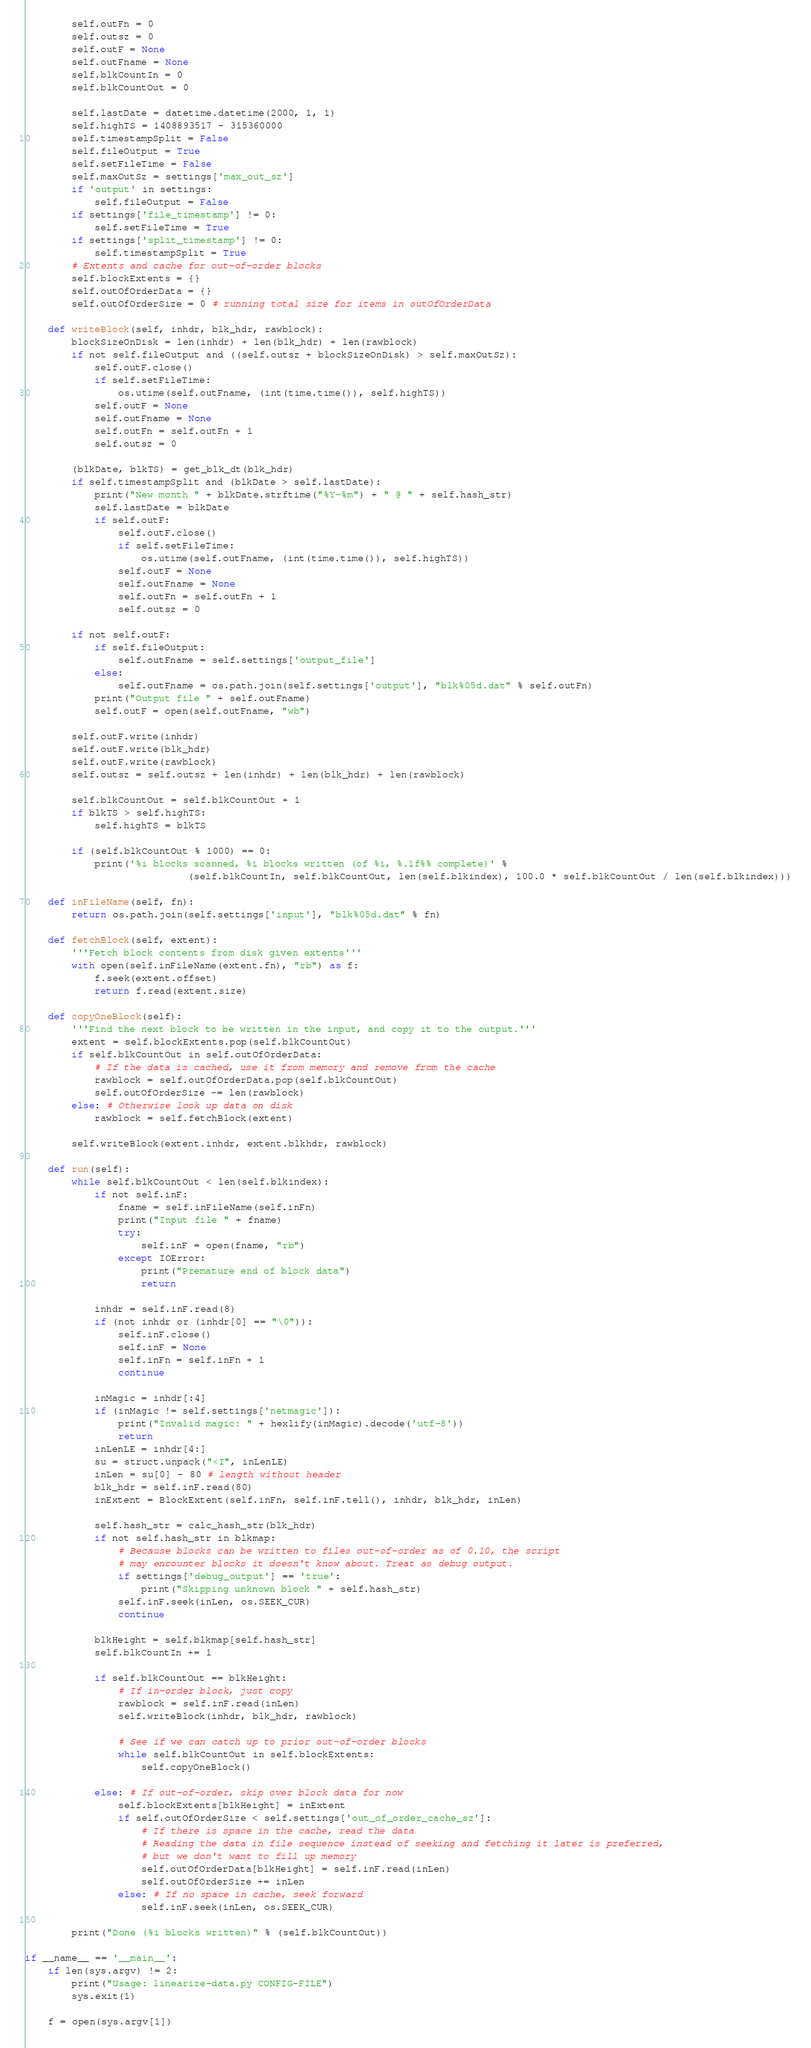Convert code to text. <code><loc_0><loc_0><loc_500><loc_500><_Python_>        self.outFn = 0
        self.outsz = 0
        self.outF = None
        self.outFname = None
        self.blkCountIn = 0
        self.blkCountOut = 0

        self.lastDate = datetime.datetime(2000, 1, 1)
        self.highTS = 1408893517 - 315360000
        self.timestampSplit = False
        self.fileOutput = True
        self.setFileTime = False
        self.maxOutSz = settings['max_out_sz']
        if 'output' in settings:
            self.fileOutput = False
        if settings['file_timestamp'] != 0:
            self.setFileTime = True
        if settings['split_timestamp'] != 0:
            self.timestampSplit = True
        # Extents and cache for out-of-order blocks
        self.blockExtents = {}
        self.outOfOrderData = {}
        self.outOfOrderSize = 0 # running total size for items in outOfOrderData

    def writeBlock(self, inhdr, blk_hdr, rawblock):
        blockSizeOnDisk = len(inhdr) + len(blk_hdr) + len(rawblock)
        if not self.fileOutput and ((self.outsz + blockSizeOnDisk) > self.maxOutSz):
            self.outF.close()
            if self.setFileTime:
                os.utime(self.outFname, (int(time.time()), self.highTS))
            self.outF = None
            self.outFname = None
            self.outFn = self.outFn + 1
            self.outsz = 0

        (blkDate, blkTS) = get_blk_dt(blk_hdr)
        if self.timestampSplit and (blkDate > self.lastDate):
            print("New month " + blkDate.strftime("%Y-%m") + " @ " + self.hash_str)
            self.lastDate = blkDate
            if self.outF:
                self.outF.close()
                if self.setFileTime:
                    os.utime(self.outFname, (int(time.time()), self.highTS))
                self.outF = None
                self.outFname = None
                self.outFn = self.outFn + 1
                self.outsz = 0

        if not self.outF:
            if self.fileOutput:
                self.outFname = self.settings['output_file']
            else:
                self.outFname = os.path.join(self.settings['output'], "blk%05d.dat" % self.outFn)
            print("Output file " + self.outFname)
            self.outF = open(self.outFname, "wb")

        self.outF.write(inhdr)
        self.outF.write(blk_hdr)
        self.outF.write(rawblock)
        self.outsz = self.outsz + len(inhdr) + len(blk_hdr) + len(rawblock)

        self.blkCountOut = self.blkCountOut + 1
        if blkTS > self.highTS:
            self.highTS = blkTS

        if (self.blkCountOut % 1000) == 0:
            print('%i blocks scanned, %i blocks written (of %i, %.1f%% complete)' %
                            (self.blkCountIn, self.blkCountOut, len(self.blkindex), 100.0 * self.blkCountOut / len(self.blkindex)))

    def inFileName(self, fn):
        return os.path.join(self.settings['input'], "blk%05d.dat" % fn)

    def fetchBlock(self, extent):
        '''Fetch block contents from disk given extents'''
        with open(self.inFileName(extent.fn), "rb") as f:
            f.seek(extent.offset)
            return f.read(extent.size)

    def copyOneBlock(self):
        '''Find the next block to be written in the input, and copy it to the output.'''
        extent = self.blockExtents.pop(self.blkCountOut)
        if self.blkCountOut in self.outOfOrderData:
            # If the data is cached, use it from memory and remove from the cache
            rawblock = self.outOfOrderData.pop(self.blkCountOut)
            self.outOfOrderSize -= len(rawblock)
        else: # Otherwise look up data on disk
            rawblock = self.fetchBlock(extent)

        self.writeBlock(extent.inhdr, extent.blkhdr, rawblock)

    def run(self):
        while self.blkCountOut < len(self.blkindex):
            if not self.inF:
                fname = self.inFileName(self.inFn)
                print("Input file " + fname)
                try:
                    self.inF = open(fname, "rb")
                except IOError:
                    print("Premature end of block data")
                    return

            inhdr = self.inF.read(8)
            if (not inhdr or (inhdr[0] == "\0")):
                self.inF.close()
                self.inF = None
                self.inFn = self.inFn + 1
                continue

            inMagic = inhdr[:4]
            if (inMagic != self.settings['netmagic']):
                print("Invalid magic: " + hexlify(inMagic).decode('utf-8'))
                return
            inLenLE = inhdr[4:]
            su = struct.unpack("<I", inLenLE)
            inLen = su[0] - 80 # length without header
            blk_hdr = self.inF.read(80)
            inExtent = BlockExtent(self.inFn, self.inF.tell(), inhdr, blk_hdr, inLen)

            self.hash_str = calc_hash_str(blk_hdr)
            if not self.hash_str in blkmap:
                # Because blocks can be written to files out-of-order as of 0.10, the script
                # may encounter blocks it doesn't know about. Treat as debug output.
                if settings['debug_output'] == 'true':
                    print("Skipping unknown block " + self.hash_str)
                self.inF.seek(inLen, os.SEEK_CUR)
                continue

            blkHeight = self.blkmap[self.hash_str]
            self.blkCountIn += 1

            if self.blkCountOut == blkHeight:
                # If in-order block, just copy
                rawblock = self.inF.read(inLen)
                self.writeBlock(inhdr, blk_hdr, rawblock)

                # See if we can catch up to prior out-of-order blocks
                while self.blkCountOut in self.blockExtents:
                    self.copyOneBlock()

            else: # If out-of-order, skip over block data for now
                self.blockExtents[blkHeight] = inExtent
                if self.outOfOrderSize < self.settings['out_of_order_cache_sz']:
                    # If there is space in the cache, read the data
                    # Reading the data in file sequence instead of seeking and fetching it later is preferred,
                    # but we don't want to fill up memory
                    self.outOfOrderData[blkHeight] = self.inF.read(inLen)
                    self.outOfOrderSize += inLen
                else: # If no space in cache, seek forward
                    self.inF.seek(inLen, os.SEEK_CUR)

        print("Done (%i blocks written)" % (self.blkCountOut))

if __name__ == '__main__':
    if len(sys.argv) != 2:
        print("Usage: linearize-data.py CONFIG-FILE")
        sys.exit(1)

    f = open(sys.argv[1])</code> 